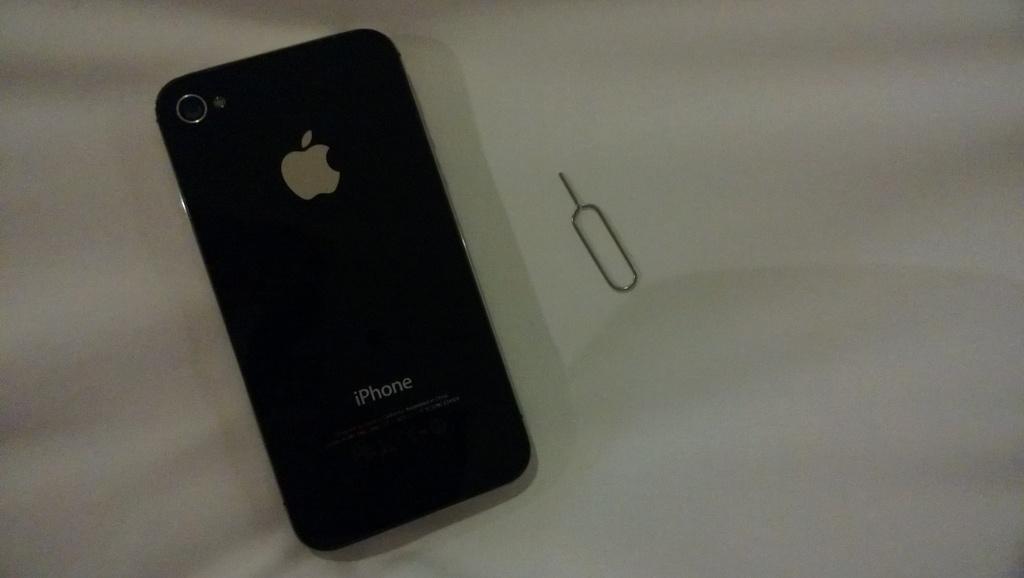What brand of phone?
Make the answer very short. Iphone. What logo is on the phone?
Your response must be concise. Apple. 